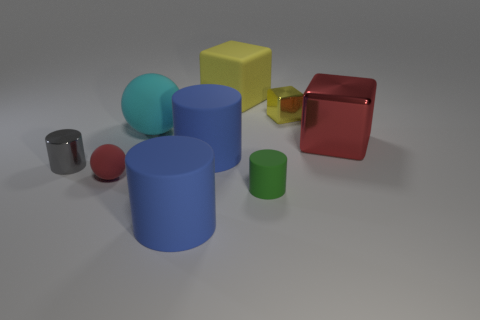What can you tell me about the composition of the objects? The objects are arranged in a way that presents a balance of shapes and colors. They are spaced out across the image, with a large blue cylinder at the center acting as an anchor. The smaller objects—like the spheres and small cylinders—are spread around this central piece. The color palette is varied but harmonious, with primary colors alongside neutral grays, which suggests a thoughtful composition meant to draw the viewer's eye around the image. 